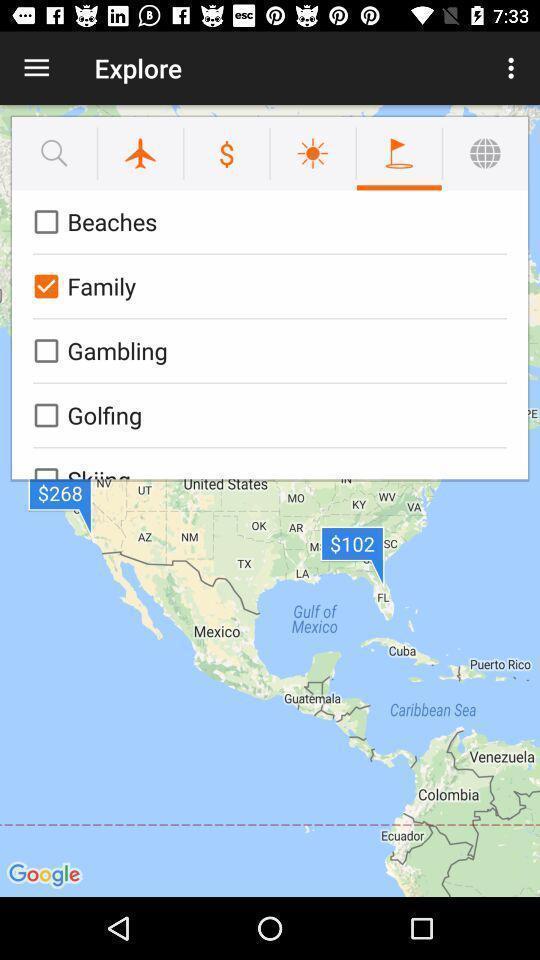What can you discern from this picture? Page displaying with different categories to explore. 